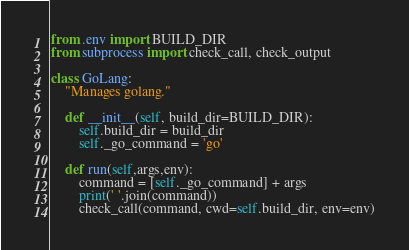Convert code to text. <code><loc_0><loc_0><loc_500><loc_500><_Python_>from .env import BUILD_DIR
from subprocess import check_call, check_output

class GoLang:
    "Manages golang."

    def __init__(self, build_dir=BUILD_DIR):
        self.build_dir = build_dir
        self._go_command = 'go'

    def run(self,args,env):
        command = [self._go_command] + args
        print(' '.join(command))
        check_call(command, cwd=self.build_dir, env=env)</code> 